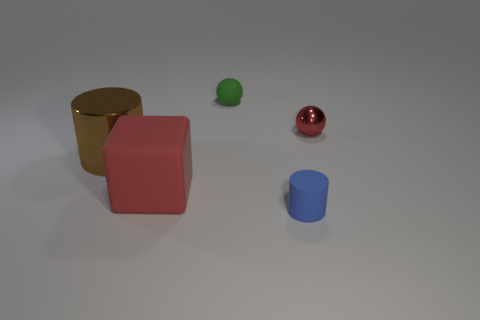Does the red metallic ball have the same size as the red thing that is in front of the brown metallic cylinder?
Make the answer very short. No. Are there an equal number of shiny balls that are in front of the big matte object and large red blocks that are to the right of the red metal thing?
Offer a very short reply. Yes. There is a thing that is the same color as the block; what is its shape?
Offer a terse response. Sphere. There is a big thing on the right side of the large metal object; what is its material?
Offer a very short reply. Rubber. Do the blue rubber object and the red metal thing have the same size?
Keep it short and to the point. Yes. Is the number of big things on the left side of the tiny rubber cylinder greater than the number of small cyan matte cylinders?
Your answer should be compact. Yes. There is a brown thing that is the same material as the tiny red ball; what size is it?
Make the answer very short. Large. There is a green thing; are there any red things on the right side of it?
Your answer should be very brief. Yes. Do the brown shiny thing and the small blue rubber thing have the same shape?
Keep it short and to the point. Yes. What is the size of the rubber object on the left side of the sphere left of the red thing that is behind the large brown cylinder?
Your response must be concise. Large. 